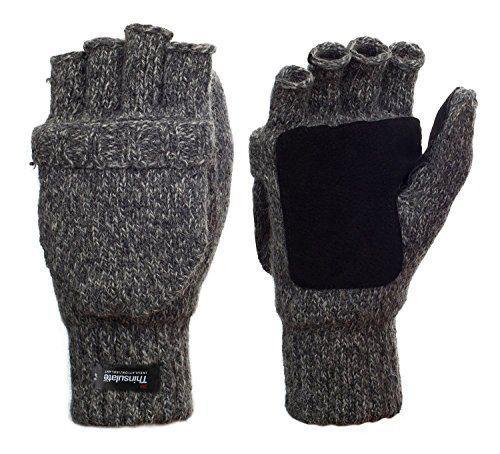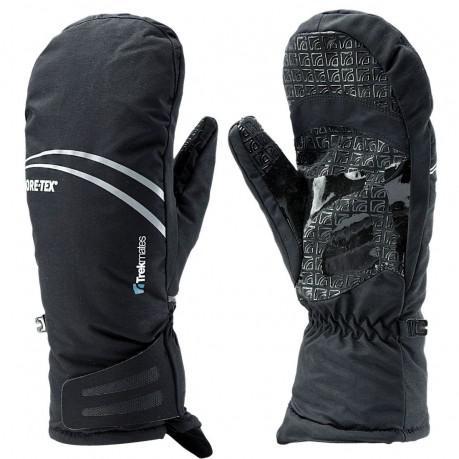The first image is the image on the left, the second image is the image on the right. For the images displayed, is the sentence "There is a matching set of right and left hand gloves." factually correct? Answer yes or no. Yes. The first image is the image on the left, the second image is the image on the right. Considering the images on both sides, is "Each image shows the front and back of a pair of black mittens with no individual fingers, and no pair of mittens has overlapping individual mittens." valid? Answer yes or no. No. 